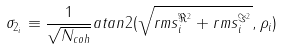<formula> <loc_0><loc_0><loc_500><loc_500>\sigma _ { 2 _ { i } } \equiv \frac { 1 } { \sqrt { N _ { c o h } } } a t a n 2 ( \sqrt { r m s _ { i } ^ { \Re ^ { 2 } } + r m s _ { i } ^ { \Im ^ { 2 } } } , \rho _ { i } )</formula> 